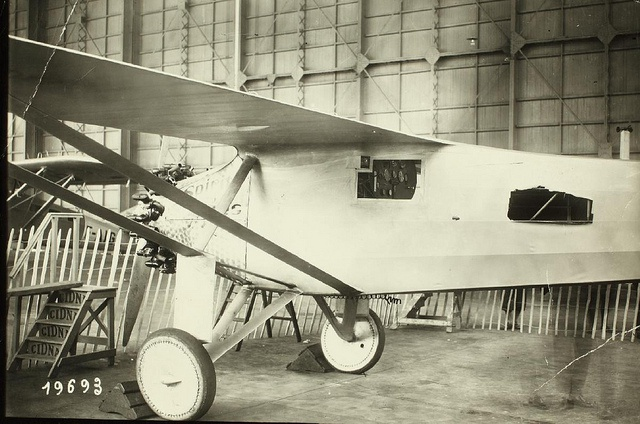Describe the objects in this image and their specific colors. I can see a airplane in black, beige, gray, and darkgray tones in this image. 